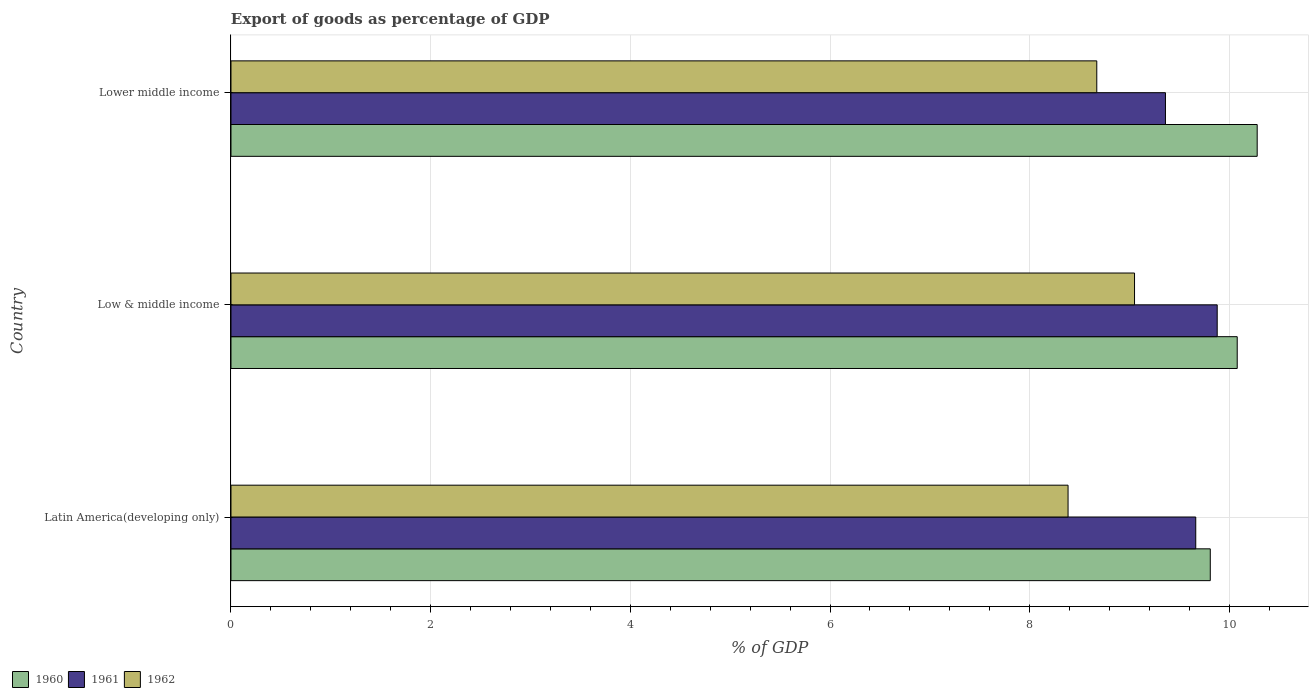How many different coloured bars are there?
Make the answer very short. 3. Are the number of bars per tick equal to the number of legend labels?
Offer a terse response. Yes. How many bars are there on the 1st tick from the top?
Your response must be concise. 3. What is the label of the 1st group of bars from the top?
Ensure brevity in your answer.  Lower middle income. What is the export of goods as percentage of GDP in 1962 in Low & middle income?
Keep it short and to the point. 9.05. Across all countries, what is the maximum export of goods as percentage of GDP in 1961?
Your answer should be compact. 9.88. Across all countries, what is the minimum export of goods as percentage of GDP in 1962?
Make the answer very short. 8.38. In which country was the export of goods as percentage of GDP in 1961 maximum?
Ensure brevity in your answer.  Low & middle income. In which country was the export of goods as percentage of GDP in 1961 minimum?
Your answer should be compact. Lower middle income. What is the total export of goods as percentage of GDP in 1960 in the graph?
Your answer should be very brief. 30.17. What is the difference between the export of goods as percentage of GDP in 1962 in Latin America(developing only) and that in Low & middle income?
Provide a short and direct response. -0.67. What is the difference between the export of goods as percentage of GDP in 1960 in Lower middle income and the export of goods as percentage of GDP in 1962 in Low & middle income?
Give a very brief answer. 1.23. What is the average export of goods as percentage of GDP in 1962 per country?
Your response must be concise. 8.7. What is the difference between the export of goods as percentage of GDP in 1961 and export of goods as percentage of GDP in 1960 in Lower middle income?
Your answer should be very brief. -0.92. In how many countries, is the export of goods as percentage of GDP in 1962 greater than 10 %?
Provide a succinct answer. 0. What is the ratio of the export of goods as percentage of GDP in 1962 in Latin America(developing only) to that in Low & middle income?
Ensure brevity in your answer.  0.93. What is the difference between the highest and the second highest export of goods as percentage of GDP in 1962?
Make the answer very short. 0.38. What is the difference between the highest and the lowest export of goods as percentage of GDP in 1961?
Offer a terse response. 0.52. In how many countries, is the export of goods as percentage of GDP in 1960 greater than the average export of goods as percentage of GDP in 1960 taken over all countries?
Offer a terse response. 2. Is the sum of the export of goods as percentage of GDP in 1962 in Latin America(developing only) and Low & middle income greater than the maximum export of goods as percentage of GDP in 1961 across all countries?
Give a very brief answer. Yes. What does the 2nd bar from the bottom in Lower middle income represents?
Offer a very short reply. 1961. How many countries are there in the graph?
Keep it short and to the point. 3. Does the graph contain any zero values?
Provide a succinct answer. No. Does the graph contain grids?
Provide a succinct answer. Yes. How many legend labels are there?
Provide a succinct answer. 3. How are the legend labels stacked?
Your response must be concise. Horizontal. What is the title of the graph?
Provide a short and direct response. Export of goods as percentage of GDP. What is the label or title of the X-axis?
Offer a very short reply. % of GDP. What is the label or title of the Y-axis?
Keep it short and to the point. Country. What is the % of GDP in 1960 in Latin America(developing only)?
Give a very brief answer. 9.81. What is the % of GDP of 1961 in Latin America(developing only)?
Keep it short and to the point. 9.66. What is the % of GDP of 1962 in Latin America(developing only)?
Provide a short and direct response. 8.38. What is the % of GDP of 1960 in Low & middle income?
Provide a succinct answer. 10.08. What is the % of GDP in 1961 in Low & middle income?
Your answer should be very brief. 9.88. What is the % of GDP in 1962 in Low & middle income?
Your answer should be compact. 9.05. What is the % of GDP of 1960 in Lower middle income?
Give a very brief answer. 10.28. What is the % of GDP of 1961 in Lower middle income?
Keep it short and to the point. 9.36. What is the % of GDP in 1962 in Lower middle income?
Offer a terse response. 8.67. Across all countries, what is the maximum % of GDP of 1960?
Ensure brevity in your answer.  10.28. Across all countries, what is the maximum % of GDP in 1961?
Provide a short and direct response. 9.88. Across all countries, what is the maximum % of GDP in 1962?
Provide a short and direct response. 9.05. Across all countries, what is the minimum % of GDP of 1960?
Your answer should be very brief. 9.81. Across all countries, what is the minimum % of GDP in 1961?
Your answer should be compact. 9.36. Across all countries, what is the minimum % of GDP of 1962?
Provide a succinct answer. 8.38. What is the total % of GDP in 1960 in the graph?
Offer a terse response. 30.17. What is the total % of GDP of 1961 in the graph?
Offer a very short reply. 28.9. What is the total % of GDP of 1962 in the graph?
Offer a terse response. 26.11. What is the difference between the % of GDP in 1960 in Latin America(developing only) and that in Low & middle income?
Your answer should be compact. -0.27. What is the difference between the % of GDP of 1961 in Latin America(developing only) and that in Low & middle income?
Keep it short and to the point. -0.21. What is the difference between the % of GDP in 1962 in Latin America(developing only) and that in Low & middle income?
Your answer should be compact. -0.67. What is the difference between the % of GDP in 1960 in Latin America(developing only) and that in Lower middle income?
Make the answer very short. -0.47. What is the difference between the % of GDP in 1961 in Latin America(developing only) and that in Lower middle income?
Provide a succinct answer. 0.3. What is the difference between the % of GDP in 1962 in Latin America(developing only) and that in Lower middle income?
Your answer should be very brief. -0.29. What is the difference between the % of GDP in 1961 in Low & middle income and that in Lower middle income?
Your response must be concise. 0.52. What is the difference between the % of GDP in 1962 in Low & middle income and that in Lower middle income?
Your answer should be very brief. 0.38. What is the difference between the % of GDP in 1960 in Latin America(developing only) and the % of GDP in 1961 in Low & middle income?
Make the answer very short. -0.07. What is the difference between the % of GDP of 1960 in Latin America(developing only) and the % of GDP of 1962 in Low & middle income?
Your answer should be compact. 0.76. What is the difference between the % of GDP of 1961 in Latin America(developing only) and the % of GDP of 1962 in Low & middle income?
Your answer should be compact. 0.61. What is the difference between the % of GDP in 1960 in Latin America(developing only) and the % of GDP in 1961 in Lower middle income?
Your response must be concise. 0.45. What is the difference between the % of GDP in 1960 in Latin America(developing only) and the % of GDP in 1962 in Lower middle income?
Offer a terse response. 1.14. What is the difference between the % of GDP of 1960 in Low & middle income and the % of GDP of 1961 in Lower middle income?
Your answer should be compact. 0.72. What is the difference between the % of GDP in 1960 in Low & middle income and the % of GDP in 1962 in Lower middle income?
Your answer should be very brief. 1.41. What is the difference between the % of GDP in 1961 in Low & middle income and the % of GDP in 1962 in Lower middle income?
Ensure brevity in your answer.  1.21. What is the average % of GDP in 1960 per country?
Ensure brevity in your answer.  10.06. What is the average % of GDP of 1961 per country?
Offer a very short reply. 9.63. What is the average % of GDP in 1962 per country?
Your response must be concise. 8.7. What is the difference between the % of GDP of 1960 and % of GDP of 1961 in Latin America(developing only)?
Make the answer very short. 0.15. What is the difference between the % of GDP of 1960 and % of GDP of 1962 in Latin America(developing only)?
Your response must be concise. 1.42. What is the difference between the % of GDP in 1961 and % of GDP in 1962 in Latin America(developing only)?
Offer a terse response. 1.28. What is the difference between the % of GDP of 1960 and % of GDP of 1961 in Low & middle income?
Make the answer very short. 0.2. What is the difference between the % of GDP in 1960 and % of GDP in 1962 in Low & middle income?
Offer a very short reply. 1.03. What is the difference between the % of GDP of 1961 and % of GDP of 1962 in Low & middle income?
Your answer should be compact. 0.83. What is the difference between the % of GDP of 1960 and % of GDP of 1961 in Lower middle income?
Provide a succinct answer. 0.92. What is the difference between the % of GDP in 1960 and % of GDP in 1962 in Lower middle income?
Keep it short and to the point. 1.61. What is the difference between the % of GDP in 1961 and % of GDP in 1962 in Lower middle income?
Provide a succinct answer. 0.69. What is the ratio of the % of GDP in 1960 in Latin America(developing only) to that in Low & middle income?
Provide a short and direct response. 0.97. What is the ratio of the % of GDP of 1961 in Latin America(developing only) to that in Low & middle income?
Keep it short and to the point. 0.98. What is the ratio of the % of GDP of 1962 in Latin America(developing only) to that in Low & middle income?
Offer a very short reply. 0.93. What is the ratio of the % of GDP in 1960 in Latin America(developing only) to that in Lower middle income?
Offer a very short reply. 0.95. What is the ratio of the % of GDP in 1961 in Latin America(developing only) to that in Lower middle income?
Offer a terse response. 1.03. What is the ratio of the % of GDP of 1962 in Latin America(developing only) to that in Lower middle income?
Provide a short and direct response. 0.97. What is the ratio of the % of GDP in 1960 in Low & middle income to that in Lower middle income?
Your response must be concise. 0.98. What is the ratio of the % of GDP of 1961 in Low & middle income to that in Lower middle income?
Ensure brevity in your answer.  1.06. What is the ratio of the % of GDP in 1962 in Low & middle income to that in Lower middle income?
Provide a succinct answer. 1.04. What is the difference between the highest and the second highest % of GDP in 1960?
Keep it short and to the point. 0.2. What is the difference between the highest and the second highest % of GDP in 1961?
Offer a very short reply. 0.21. What is the difference between the highest and the second highest % of GDP in 1962?
Keep it short and to the point. 0.38. What is the difference between the highest and the lowest % of GDP in 1960?
Provide a short and direct response. 0.47. What is the difference between the highest and the lowest % of GDP in 1961?
Ensure brevity in your answer.  0.52. What is the difference between the highest and the lowest % of GDP in 1962?
Offer a very short reply. 0.67. 